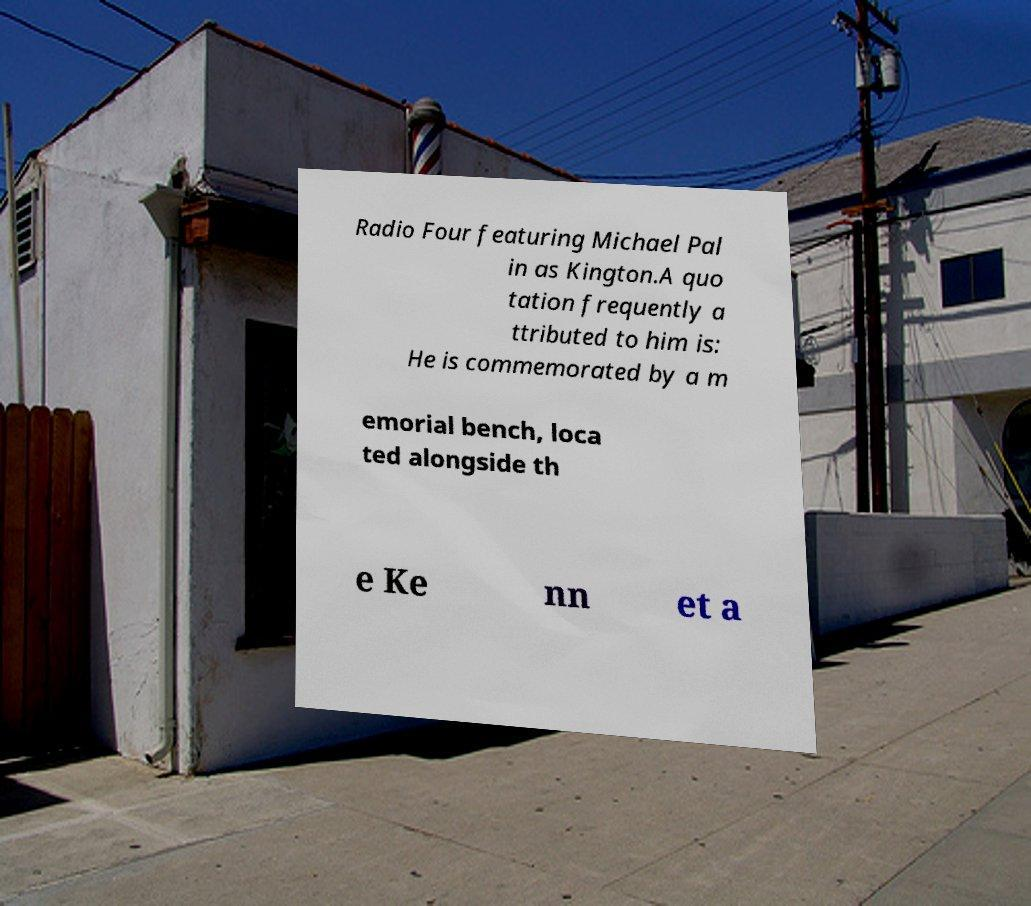There's text embedded in this image that I need extracted. Can you transcribe it verbatim? Radio Four featuring Michael Pal in as Kington.A quo tation frequently a ttributed to him is: He is commemorated by a m emorial bench, loca ted alongside th e Ke nn et a 